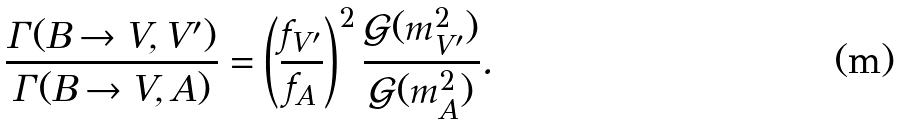Convert formula to latex. <formula><loc_0><loc_0><loc_500><loc_500>\frac { \Gamma ( B \rightarrow V , V ^ { \prime } ) } { \Gamma ( B \rightarrow V , A ) } = \left ( \frac { f _ { V ^ { \prime } } } { f _ { A } } \right ) ^ { 2 } \frac { \mathcal { G } ( m _ { V ^ { \prime } } ^ { 2 } ) } { \mathcal { G } ( m _ { A } ^ { 2 } ) } .</formula> 